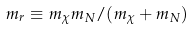<formula> <loc_0><loc_0><loc_500><loc_500>m _ { r } \equiv m _ { \chi } m _ { N } / ( m _ { \chi } + m _ { N } )</formula> 